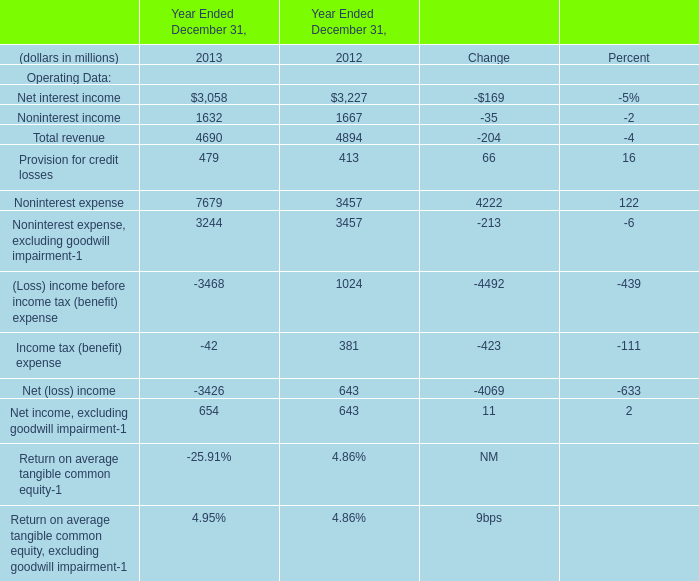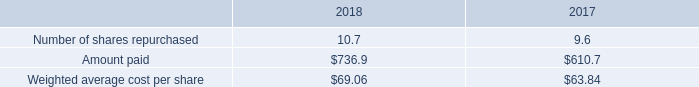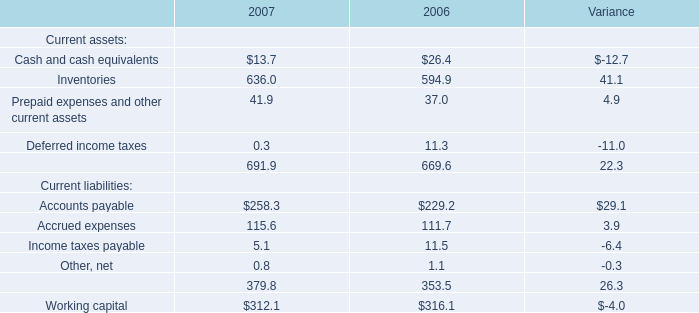In the year with largest amount of Noninterest expense, what's the increasing rate of Net interest income? 
Computations: ((3058 - 3227) / 3227)
Answer: -0.05237. 